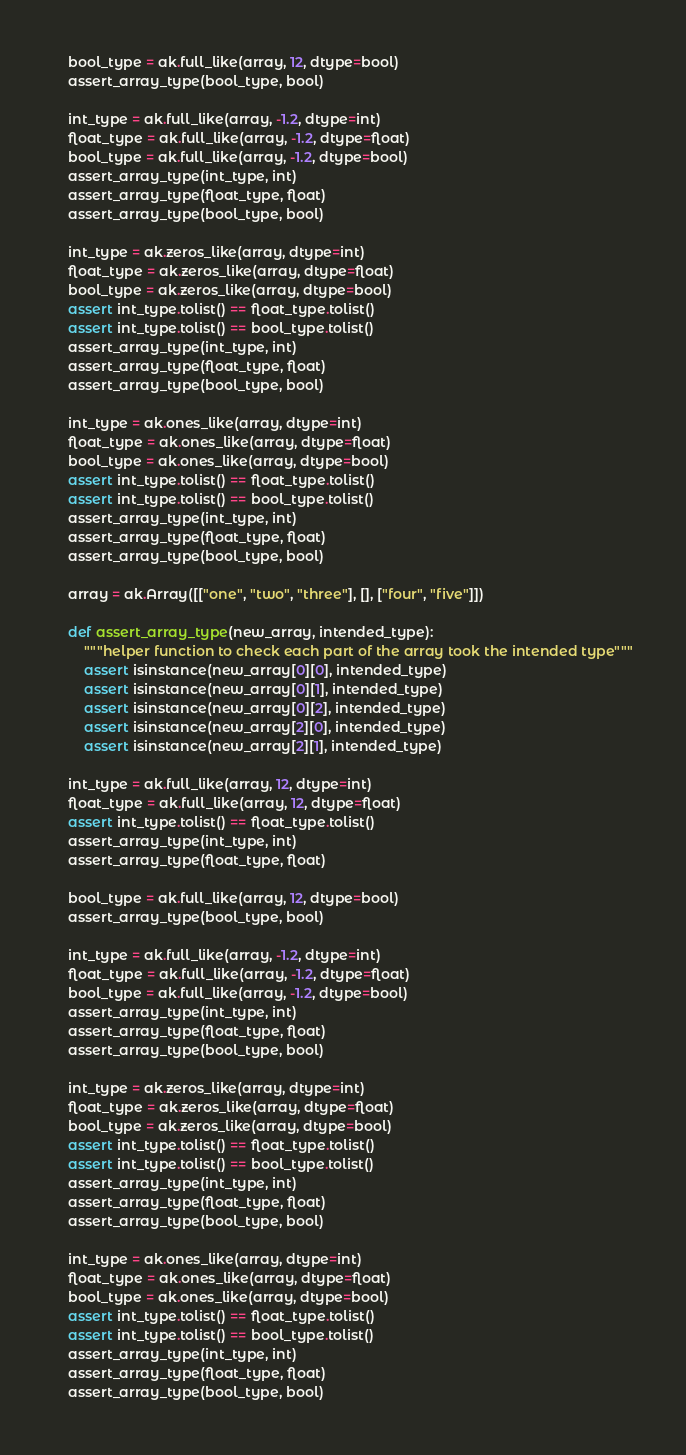<code> <loc_0><loc_0><loc_500><loc_500><_Python_>    bool_type = ak.full_like(array, 12, dtype=bool)
    assert_array_type(bool_type, bool)

    int_type = ak.full_like(array, -1.2, dtype=int)
    float_type = ak.full_like(array, -1.2, dtype=float)
    bool_type = ak.full_like(array, -1.2, dtype=bool)
    assert_array_type(int_type, int)
    assert_array_type(float_type, float)
    assert_array_type(bool_type, bool)

    int_type = ak.zeros_like(array, dtype=int)
    float_type = ak.zeros_like(array, dtype=float)
    bool_type = ak.zeros_like(array, dtype=bool)
    assert int_type.tolist() == float_type.tolist()
    assert int_type.tolist() == bool_type.tolist()
    assert_array_type(int_type, int)
    assert_array_type(float_type, float)
    assert_array_type(bool_type, bool)

    int_type = ak.ones_like(array, dtype=int)
    float_type = ak.ones_like(array, dtype=float)
    bool_type = ak.ones_like(array, dtype=bool)
    assert int_type.tolist() == float_type.tolist()
    assert int_type.tolist() == bool_type.tolist()
    assert_array_type(int_type, int)
    assert_array_type(float_type, float)
    assert_array_type(bool_type, bool)

    array = ak.Array([["one", "two", "three"], [], ["four", "five"]])

    def assert_array_type(new_array, intended_type):
        """helper function to check each part of the array took the intended type"""
        assert isinstance(new_array[0][0], intended_type)
        assert isinstance(new_array[0][1], intended_type)
        assert isinstance(new_array[0][2], intended_type)
        assert isinstance(new_array[2][0], intended_type)
        assert isinstance(new_array[2][1], intended_type)

    int_type = ak.full_like(array, 12, dtype=int)
    float_type = ak.full_like(array, 12, dtype=float)
    assert int_type.tolist() == float_type.tolist()
    assert_array_type(int_type, int)
    assert_array_type(float_type, float)

    bool_type = ak.full_like(array, 12, dtype=bool)
    assert_array_type(bool_type, bool)

    int_type = ak.full_like(array, -1.2, dtype=int)
    float_type = ak.full_like(array, -1.2, dtype=float)
    bool_type = ak.full_like(array, -1.2, dtype=bool)
    assert_array_type(int_type, int)
    assert_array_type(float_type, float)
    assert_array_type(bool_type, bool)

    int_type = ak.zeros_like(array, dtype=int)
    float_type = ak.zeros_like(array, dtype=float)
    bool_type = ak.zeros_like(array, dtype=bool)
    assert int_type.tolist() == float_type.tolist()
    assert int_type.tolist() == bool_type.tolist()
    assert_array_type(int_type, int)
    assert_array_type(float_type, float)
    assert_array_type(bool_type, bool)

    int_type = ak.ones_like(array, dtype=int)
    float_type = ak.ones_like(array, dtype=float)
    bool_type = ak.ones_like(array, dtype=bool)
    assert int_type.tolist() == float_type.tolist()
    assert int_type.tolist() == bool_type.tolist()
    assert_array_type(int_type, int)
    assert_array_type(float_type, float)
    assert_array_type(bool_type, bool)
</code> 